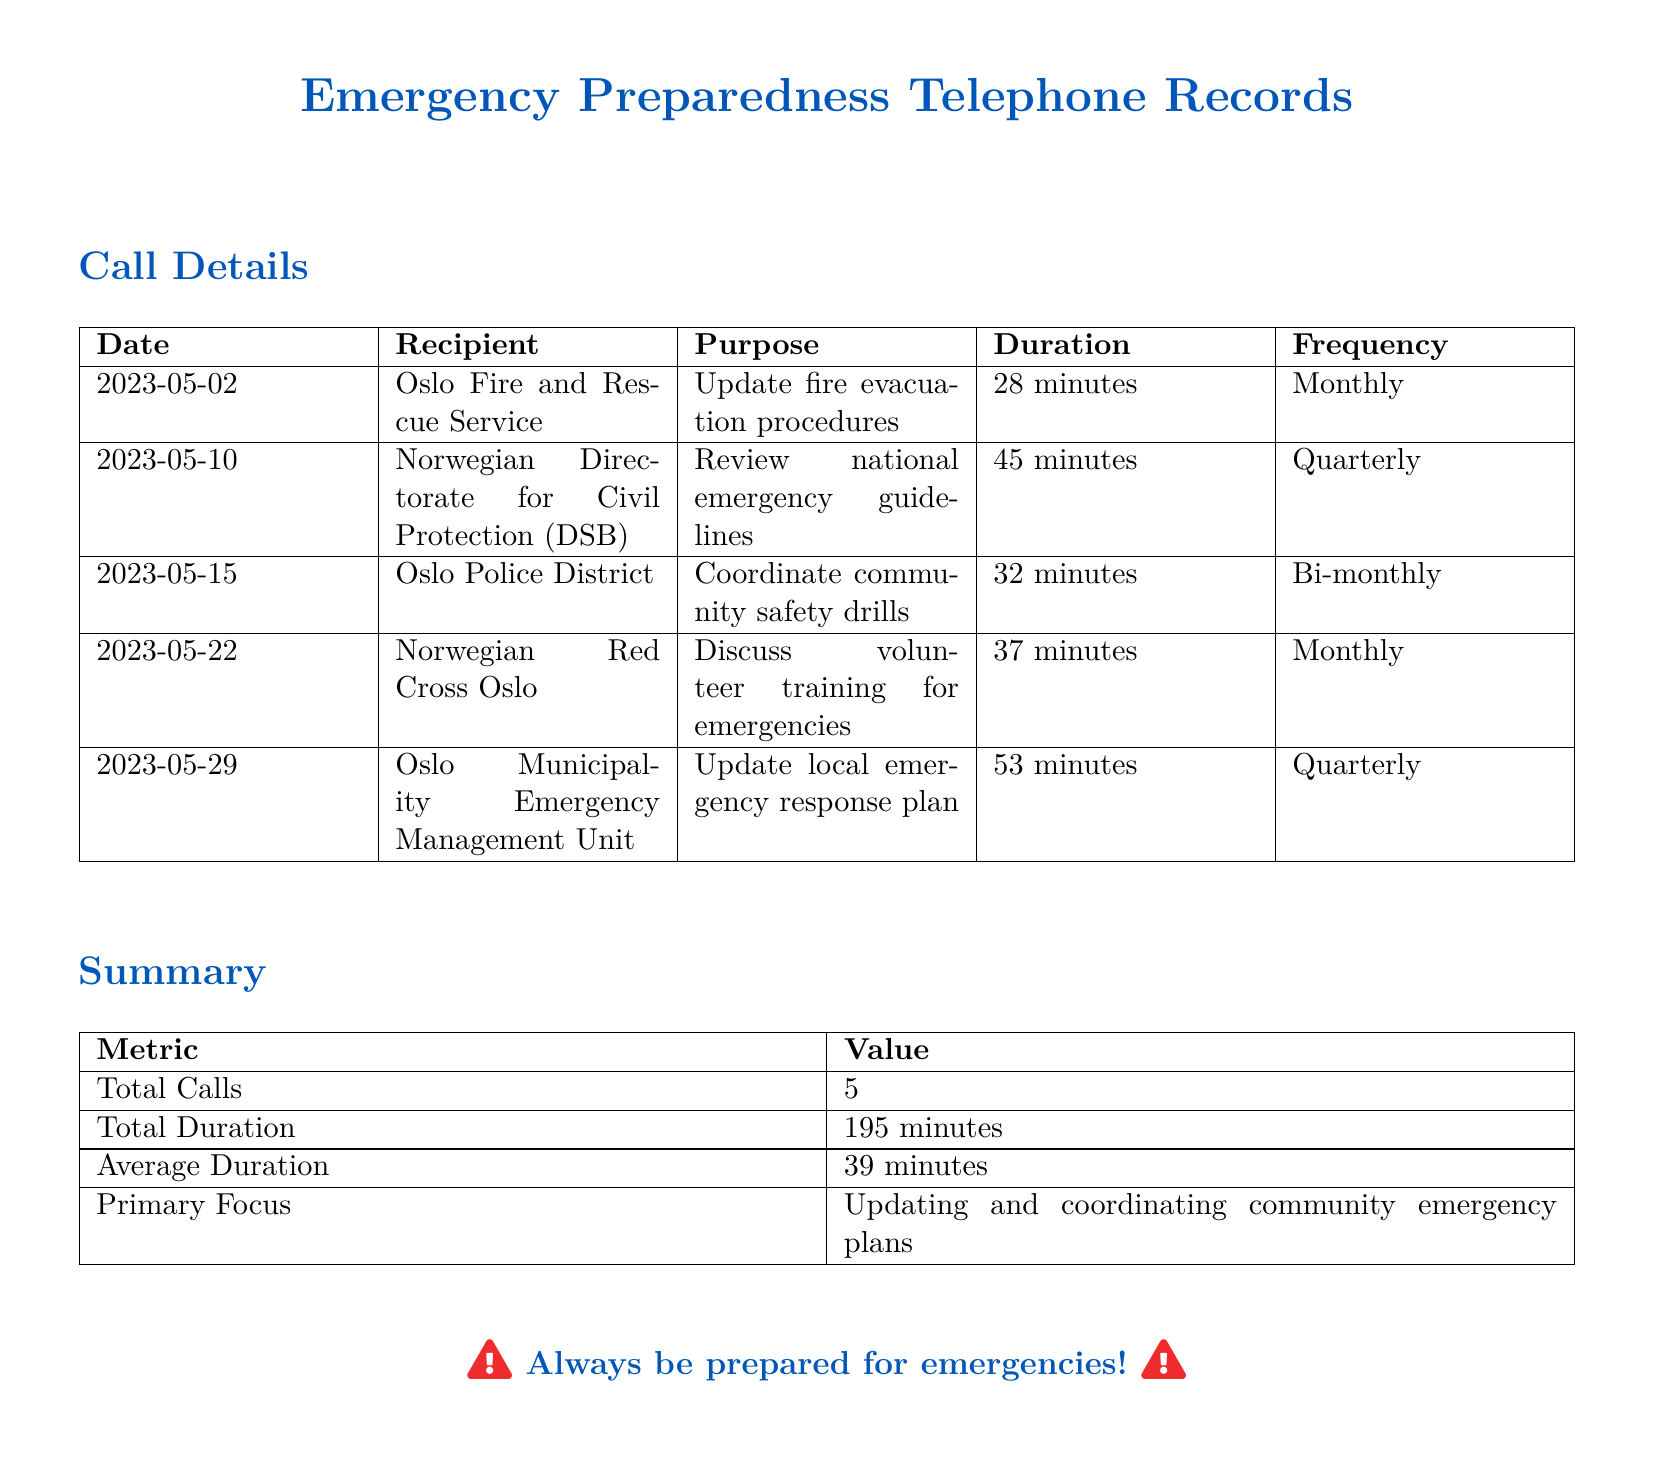What is the date of the call to the Oslo Fire and Rescue Service? The document states that the call to the Oslo Fire and Rescue Service occurred on May 2, 2023.
Answer: May 2, 2023 How long was the call with the Norwegian Directorate for Civil Protection (DSB)? The duration of the call with the Norwegian Directorate for Civil Protection (DSB) is given as 45 minutes.
Answer: 45 minutes What is the average duration of the calls? The document calculates the average duration by dividing the total duration by the number of calls, which is 195 minutes divided by 5 calls, leading to 39 minutes.
Answer: 39 minutes Which recipient had the longest call? By comparing the durations listed, the call with the Oslo Municipality Emergency Management Unit lasted the longest at 53 minutes.
Answer: Oslo Municipality Emergency Management Unit How many calls were made to review or update emergency plans? The document lists calls specifically aimed at reviewing or updating emergency plans, and there are three such calls.
Answer: 3 What is the primary focus of the calls? According to the summary, the primary focus of the calls is on updating and coordinating community emergency plans.
Answer: Updating and coordinating community emergency plans How often are the calls made to the Norwegian Red Cross Oslo? The document indicates that calls to the Norwegian Red Cross Oslo are made monthly, as shown in the frequency column.
Answer: Monthly What is the total duration of all calls combined? The total duration of all calls is explicitly stated in the summary as 195 minutes.
Answer: 195 minutes Which organization was contacted on May 29, 2023? Referring to the call details, the organization contacted on May 29, 2023, was the Oslo Municipality Emergency Management Unit.
Answer: Oslo Municipality Emergency Management Unit 